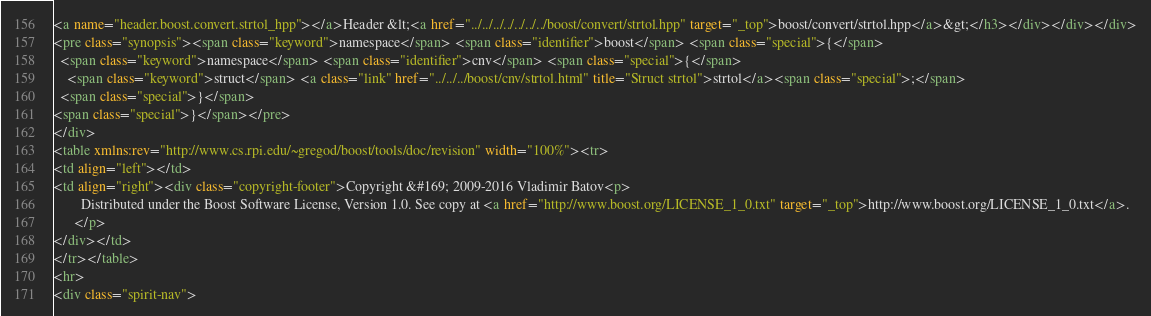Convert code to text. <code><loc_0><loc_0><loc_500><loc_500><_HTML_><a name="header.boost.convert.strtol_hpp"></a>Header &lt;<a href="../../../../../../../boost/convert/strtol.hpp" target="_top">boost/convert/strtol.hpp</a>&gt;</h3></div></div></div>
<pre class="synopsis"><span class="keyword">namespace</span> <span class="identifier">boost</span> <span class="special">{</span>
  <span class="keyword">namespace</span> <span class="identifier">cnv</span> <span class="special">{</span>
    <span class="keyword">struct</span> <a class="link" href="../../../boost/cnv/strtol.html" title="Struct strtol">strtol</a><span class="special">;</span>
  <span class="special">}</span>
<span class="special">}</span></pre>
</div>
<table xmlns:rev="http://www.cs.rpi.edu/~gregod/boost/tools/doc/revision" width="100%"><tr>
<td align="left"></td>
<td align="right"><div class="copyright-footer">Copyright &#169; 2009-2016 Vladimir Batov<p>
        Distributed under the Boost Software License, Version 1.0. See copy at <a href="http://www.boost.org/LICENSE_1_0.txt" target="_top">http://www.boost.org/LICENSE_1_0.txt</a>.
      </p>
</div></td>
</tr></table>
<hr>
<div class="spirit-nav"></code> 